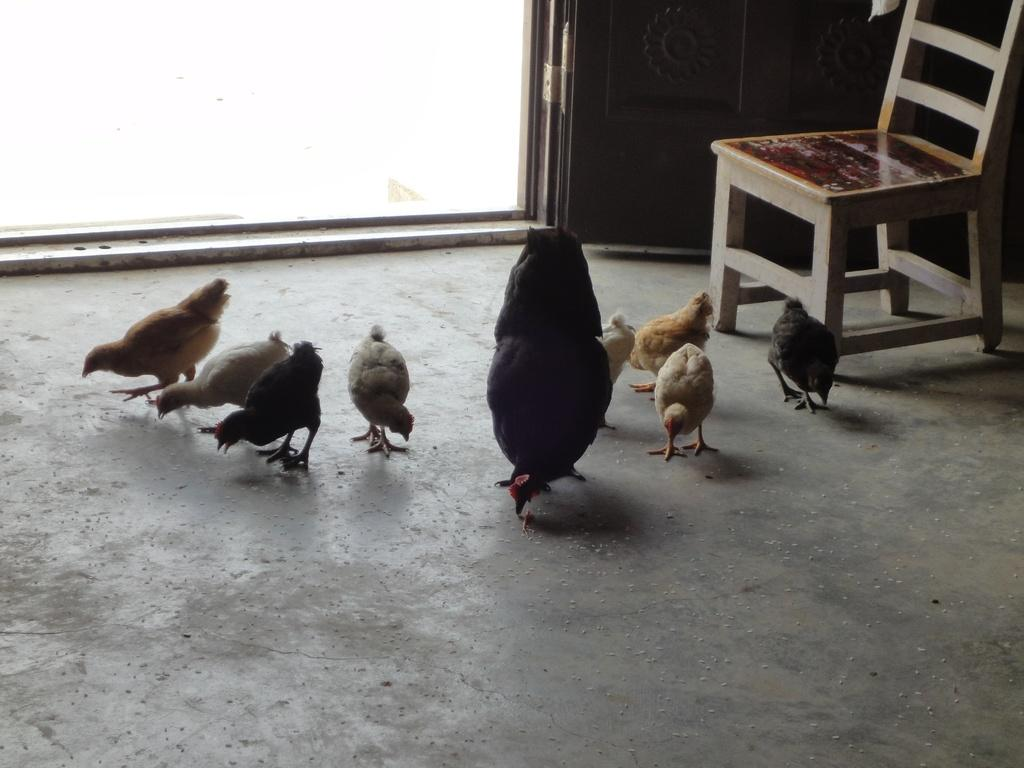What type of space is depicted in the image? There is a room in the image. What animals can be seen in the room? There are hens in the room. Is there a light bulb hanging from the ceiling in the room? There is no mention of a light bulb or any lighting fixture in the image, so it cannot be determined if there is one present. 